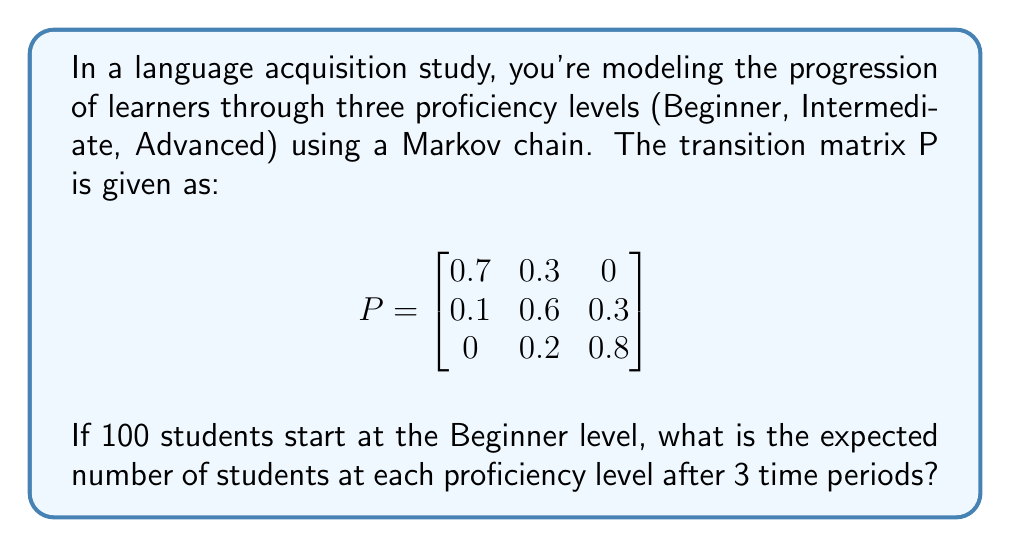Show me your answer to this math problem. To solve this problem, we'll use the properties of Markov chains and matrix multiplication. Let's approach this step-by-step:

1) The initial state vector is $v_0 = [100, 0, 0]$, representing 100 students at the Beginner level.

2) To find the state after 3 time periods, we need to multiply the initial state vector by the transition matrix P three times:

   $v_3 = v_0 \cdot P^3$

3) Let's calculate $P^2$ first:
   
   $$P^2 = \begin{bmatrix}
   0.7 & 0.3 & 0 \\
   0.1 & 0.6 & 0.3 \\
   0 & 0.2 & 0.8
   \end{bmatrix} \cdot \begin{bmatrix}
   0.7 & 0.3 & 0 \\
   0.1 & 0.6 & 0.3 \\
   0 & 0.2 & 0.8
   \end{bmatrix} = \begin{bmatrix}
   0.52 & 0.39 & 0.09 \\
   0.13 & 0.53 & 0.34 \\
   0.02 & 0.28 & 0.70
   \end{bmatrix}$$

4) Now let's calculate $P^3$:
   
   $$P^3 = P^2 \cdot P = \begin{bmatrix}
   0.52 & 0.39 & 0.09 \\
   0.13 & 0.53 & 0.34 \\
   0.02 & 0.28 & 0.70
   \end{bmatrix} \cdot \begin{bmatrix}
   0.7 & 0.3 & 0 \\
   0.1 & 0.6 & 0.3 \\
   0 & 0.2 & 0.8
   \end{bmatrix} = \begin{bmatrix}
   0.397 & 0.423 & 0.180 \\
   0.145 & 0.467 & 0.388 \\
   0.034 & 0.308 & 0.658
   \end{bmatrix}$$

5) Finally, we multiply the initial state vector by $P^3$:

   $v_3 = [100, 0, 0] \cdot \begin{bmatrix}
   0.397 & 0.423 & 0.180 \\
   0.145 & 0.467 & 0.388 \\
   0.034 & 0.308 & 0.658
   \end{bmatrix} = [39.7, 42.3, 18.0]$

6) Rounding to the nearest whole number (as we're dealing with students), we get:
   Beginner: 40, Intermediate: 42, Advanced: 18
Answer: [40, 42, 18] 